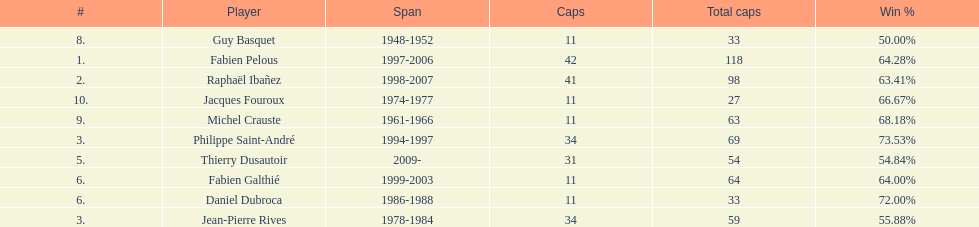How many players have spans above three years? 6. I'm looking to parse the entire table for insights. Could you assist me with that? {'header': ['#', 'Player', 'Span', 'Caps', 'Total caps', 'Win\xa0%'], 'rows': [['8.', 'Guy Basquet', '1948-1952', '11', '33', '50.00%'], ['1.', 'Fabien Pelous', '1997-2006', '42', '118', '64.28%'], ['2.', 'Raphaël Ibañez', '1998-2007', '41', '98', '63.41%'], ['10.', 'Jacques Fouroux', '1974-1977', '11', '27', '66.67%'], ['9.', 'Michel Crauste', '1961-1966', '11', '63', '68.18%'], ['3.', 'Philippe Saint-André', '1994-1997', '34', '69', '73.53%'], ['5.', 'Thierry Dusautoir', '2009-', '31', '54', '54.84%'], ['6.', 'Fabien Galthié', '1999-2003', '11', '64', '64.00%'], ['6.', 'Daniel Dubroca', '1986-1988', '11', '33', '72.00%'], ['3.', 'Jean-Pierre Rives', '1978-1984', '34', '59', '55.88%']]} 